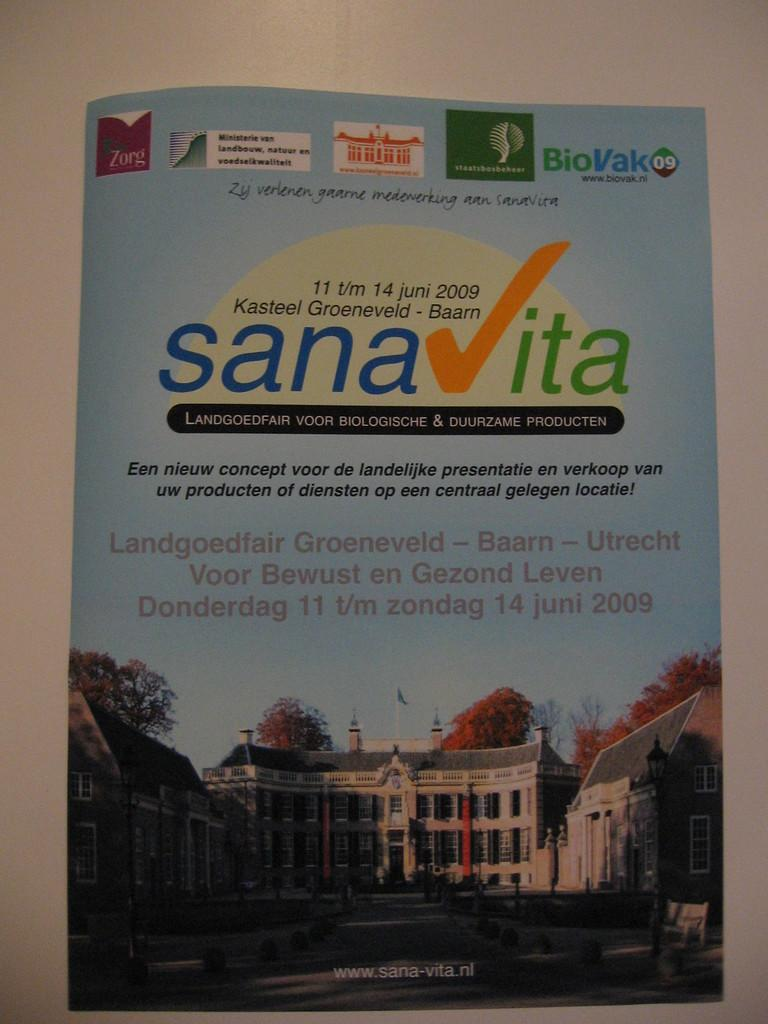Provide a one-sentence caption for the provided image. Sana vita poster thatcontains information by Kasteel Groenveld. 